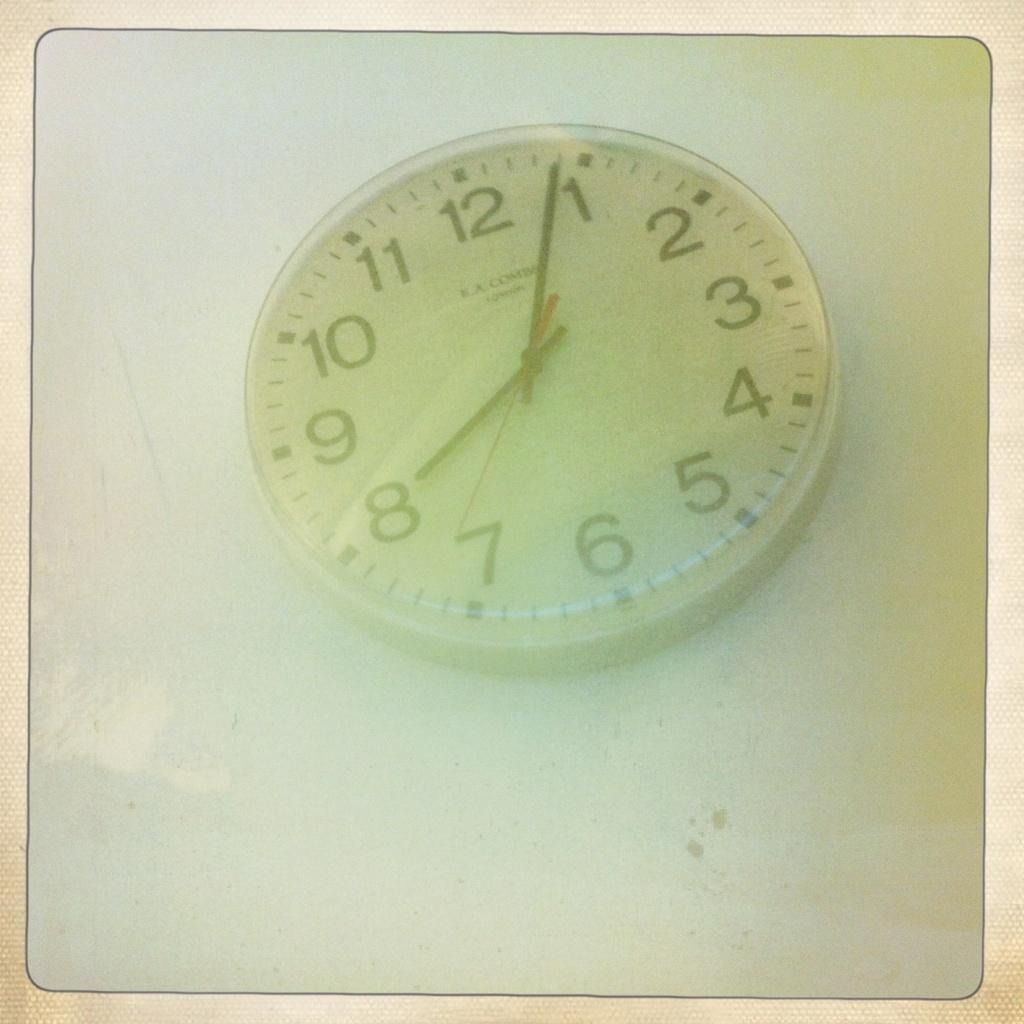<image>
Present a compact description of the photo's key features. A clock that is from the company LL Comm 